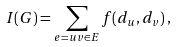Convert formula to latex. <formula><loc_0><loc_0><loc_500><loc_500>I ( G ) = \sum _ { e = u v \in E } f ( d _ { u } , d _ { v } ) \, ,</formula> 